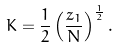Convert formula to latex. <formula><loc_0><loc_0><loc_500><loc_500>K = \frac { 1 } { 2 } \left ( \frac { z _ { 1 } } { N } \right ) ^ { \frac { 1 } { 2 } } .</formula> 